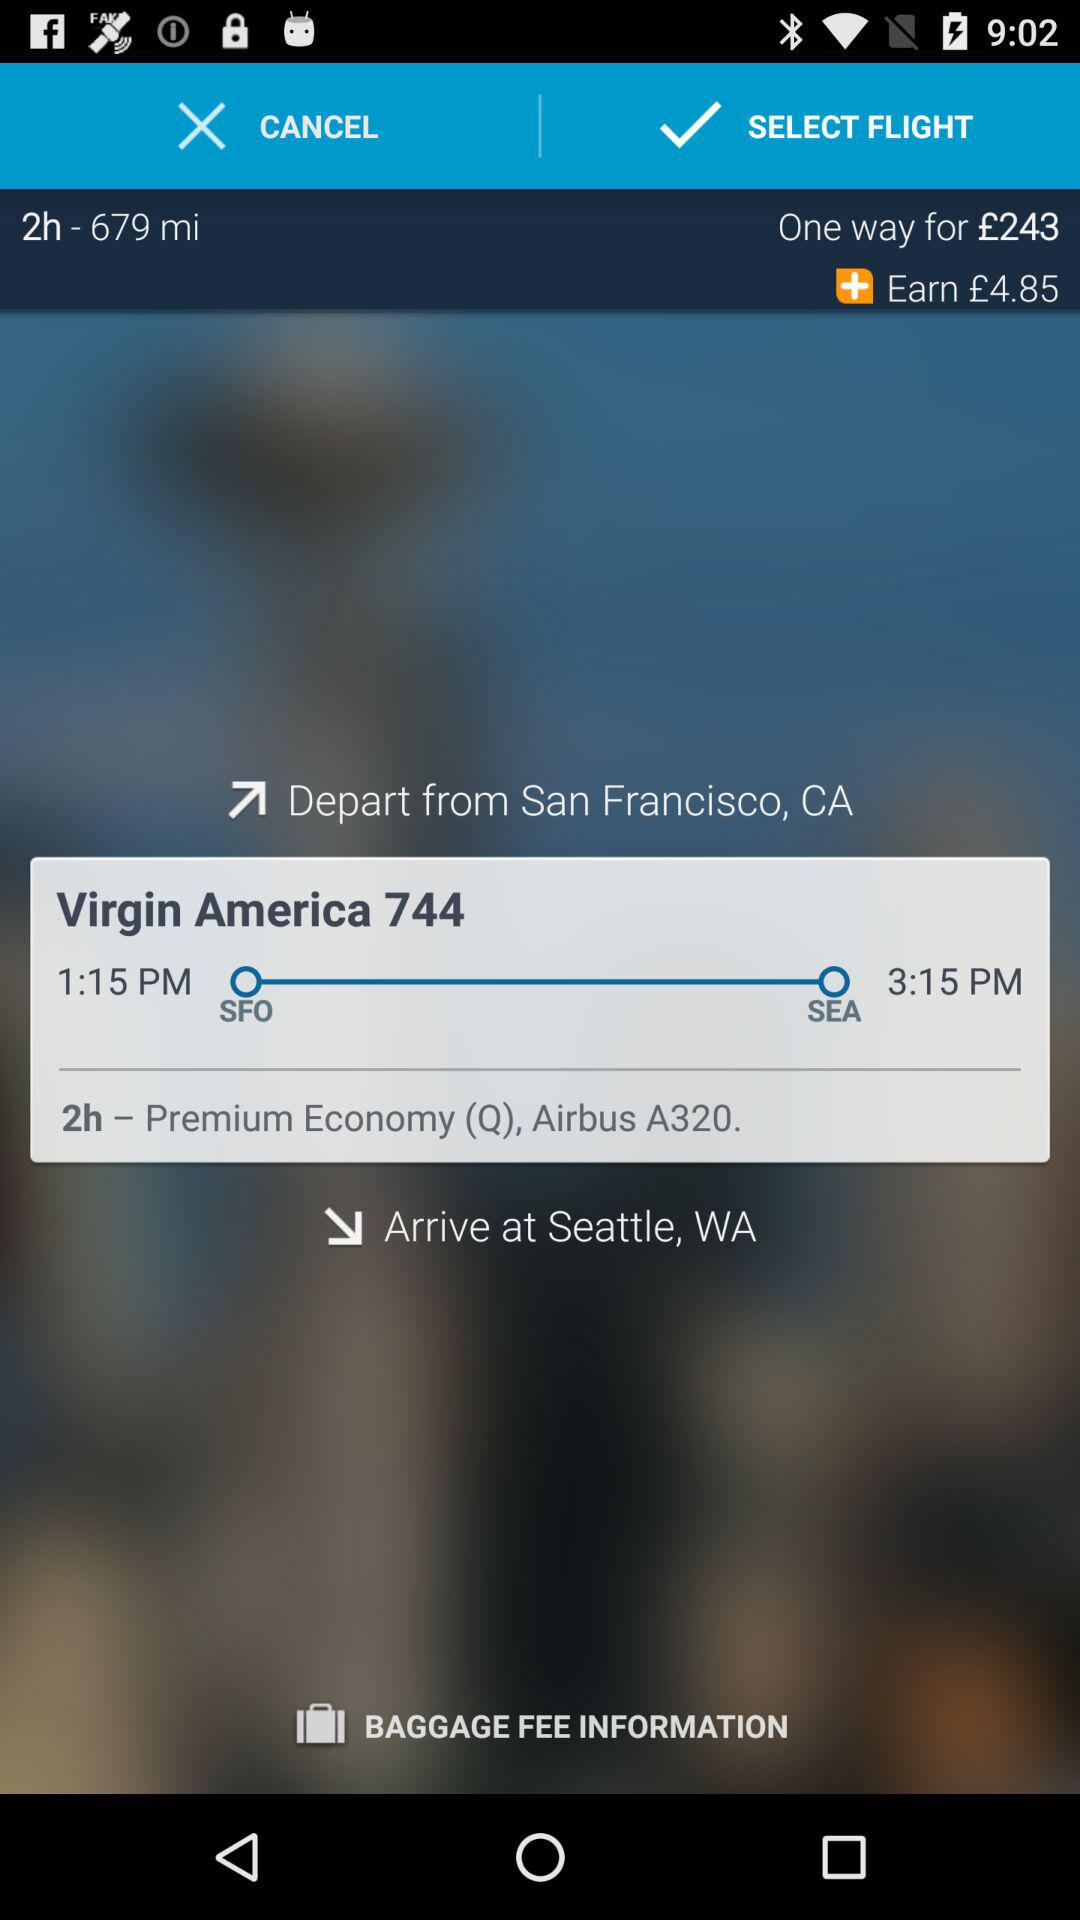Two hours of duration is given for which thing?
When the provided information is insufficient, respond with <no answer>. <no answer> 